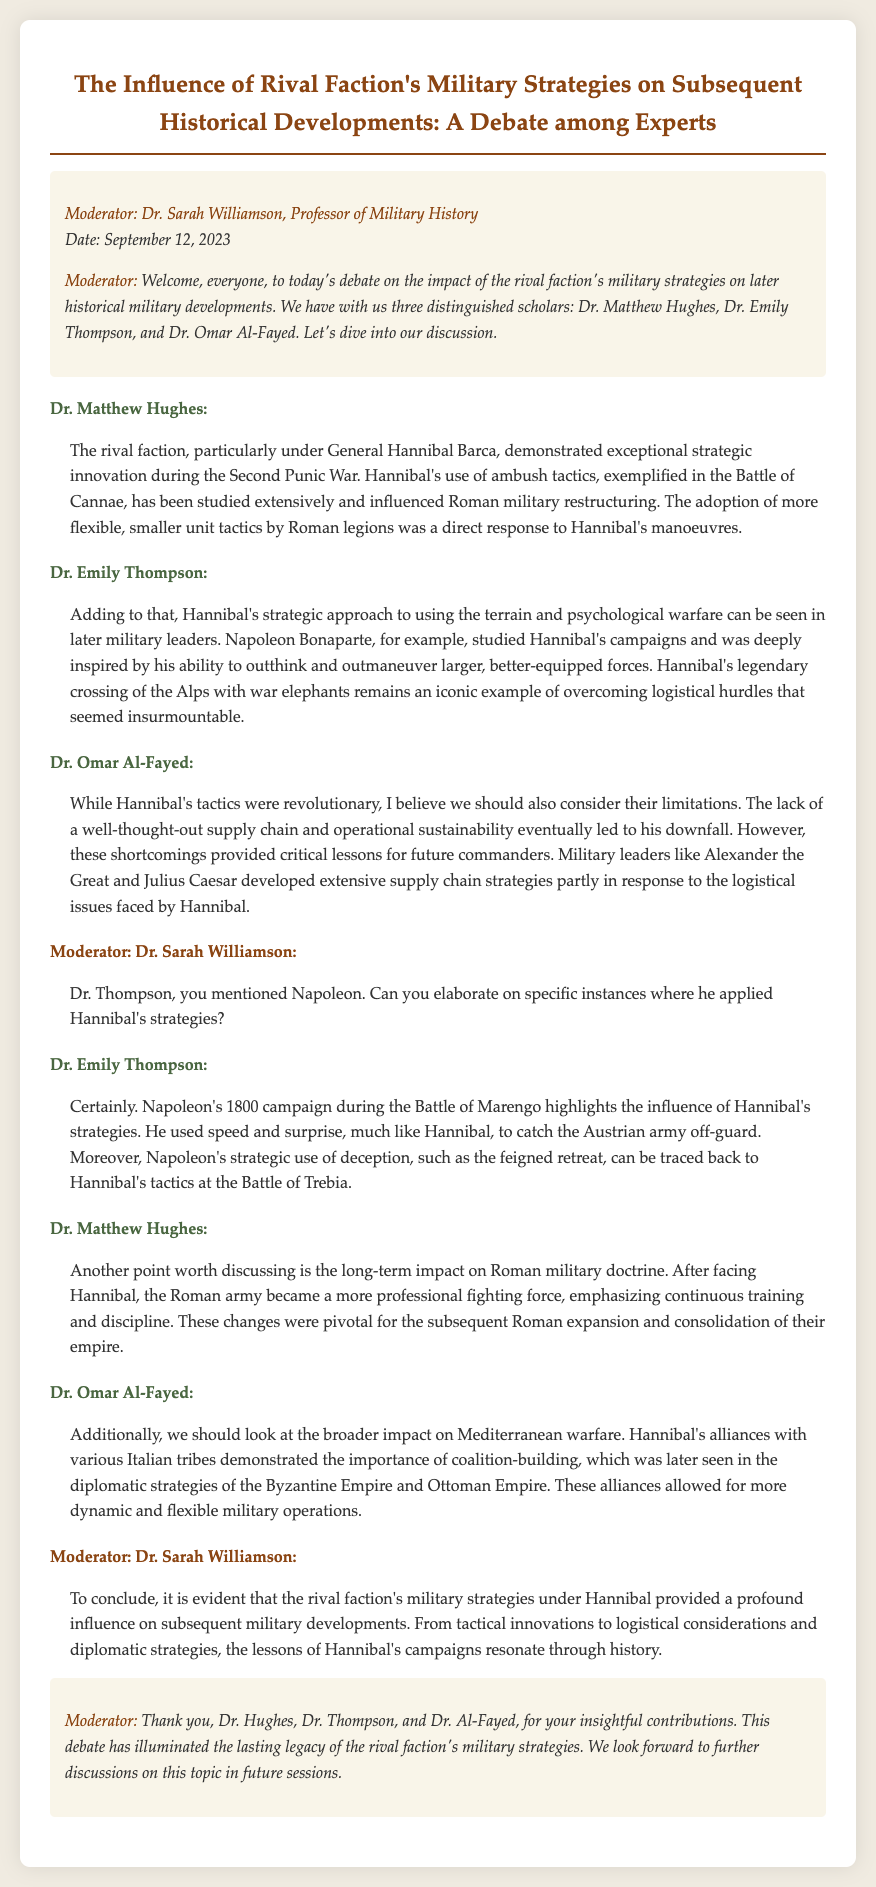What date was the debate held? The date of the debate is mentioned at the beginning of the document, which is September 12, 2023.
Answer: September 12, 2023 Who was the moderator of the debate? The moderator is introduced at the beginning of the document and is identified as Dr. Sarah Williamson.
Answer: Dr. Sarah Williamson Which general's tactics were discussed as influential? The document mentions Hannibal Barca as the key figure whose strategies influenced military developments.
Answer: Hannibal Barca What battle exemplifies Hannibal's ambush tactics? The speaker discusses the Battle of Cannae as a prominent example of Hannibal's strategic innovation.
Answer: Battle of Cannae What strategic approach did Napoleon use in his 1800 campaign? Dr. Emily Thompson highlights the use of speed and surprise in Napoleon's 1800 campaign at the Battle of Marengo.
Answer: Speed and surprise How did Hannibal influence Roman military doctrine? The document states that the Roman army became a more professional fighting force due to their experiences against Hannibal.
Answer: More professional fighting force What was a key limitation of Hannibal's tactics mentioned in the debate? Dr. Omar Al-Fayed points out the lack of a well-thought-out supply chain as a critical limitation of Hannibal's strategies.
Answer: Lack of a well-thought-out supply chain Which type of warfare did Hannibal's coalition-building impact later on? The document refers to Mediterranean warfare as being influenced by Hannibal's coalition-building strategies.
Answer: Mediterranean warfare What overall conclusion did the moderator reach about Hannibal's military strategies? The moderator concludes that Hannibal's strategies provided a profound influence on subsequent military developments.
Answer: Profound influence on subsequent military developments 